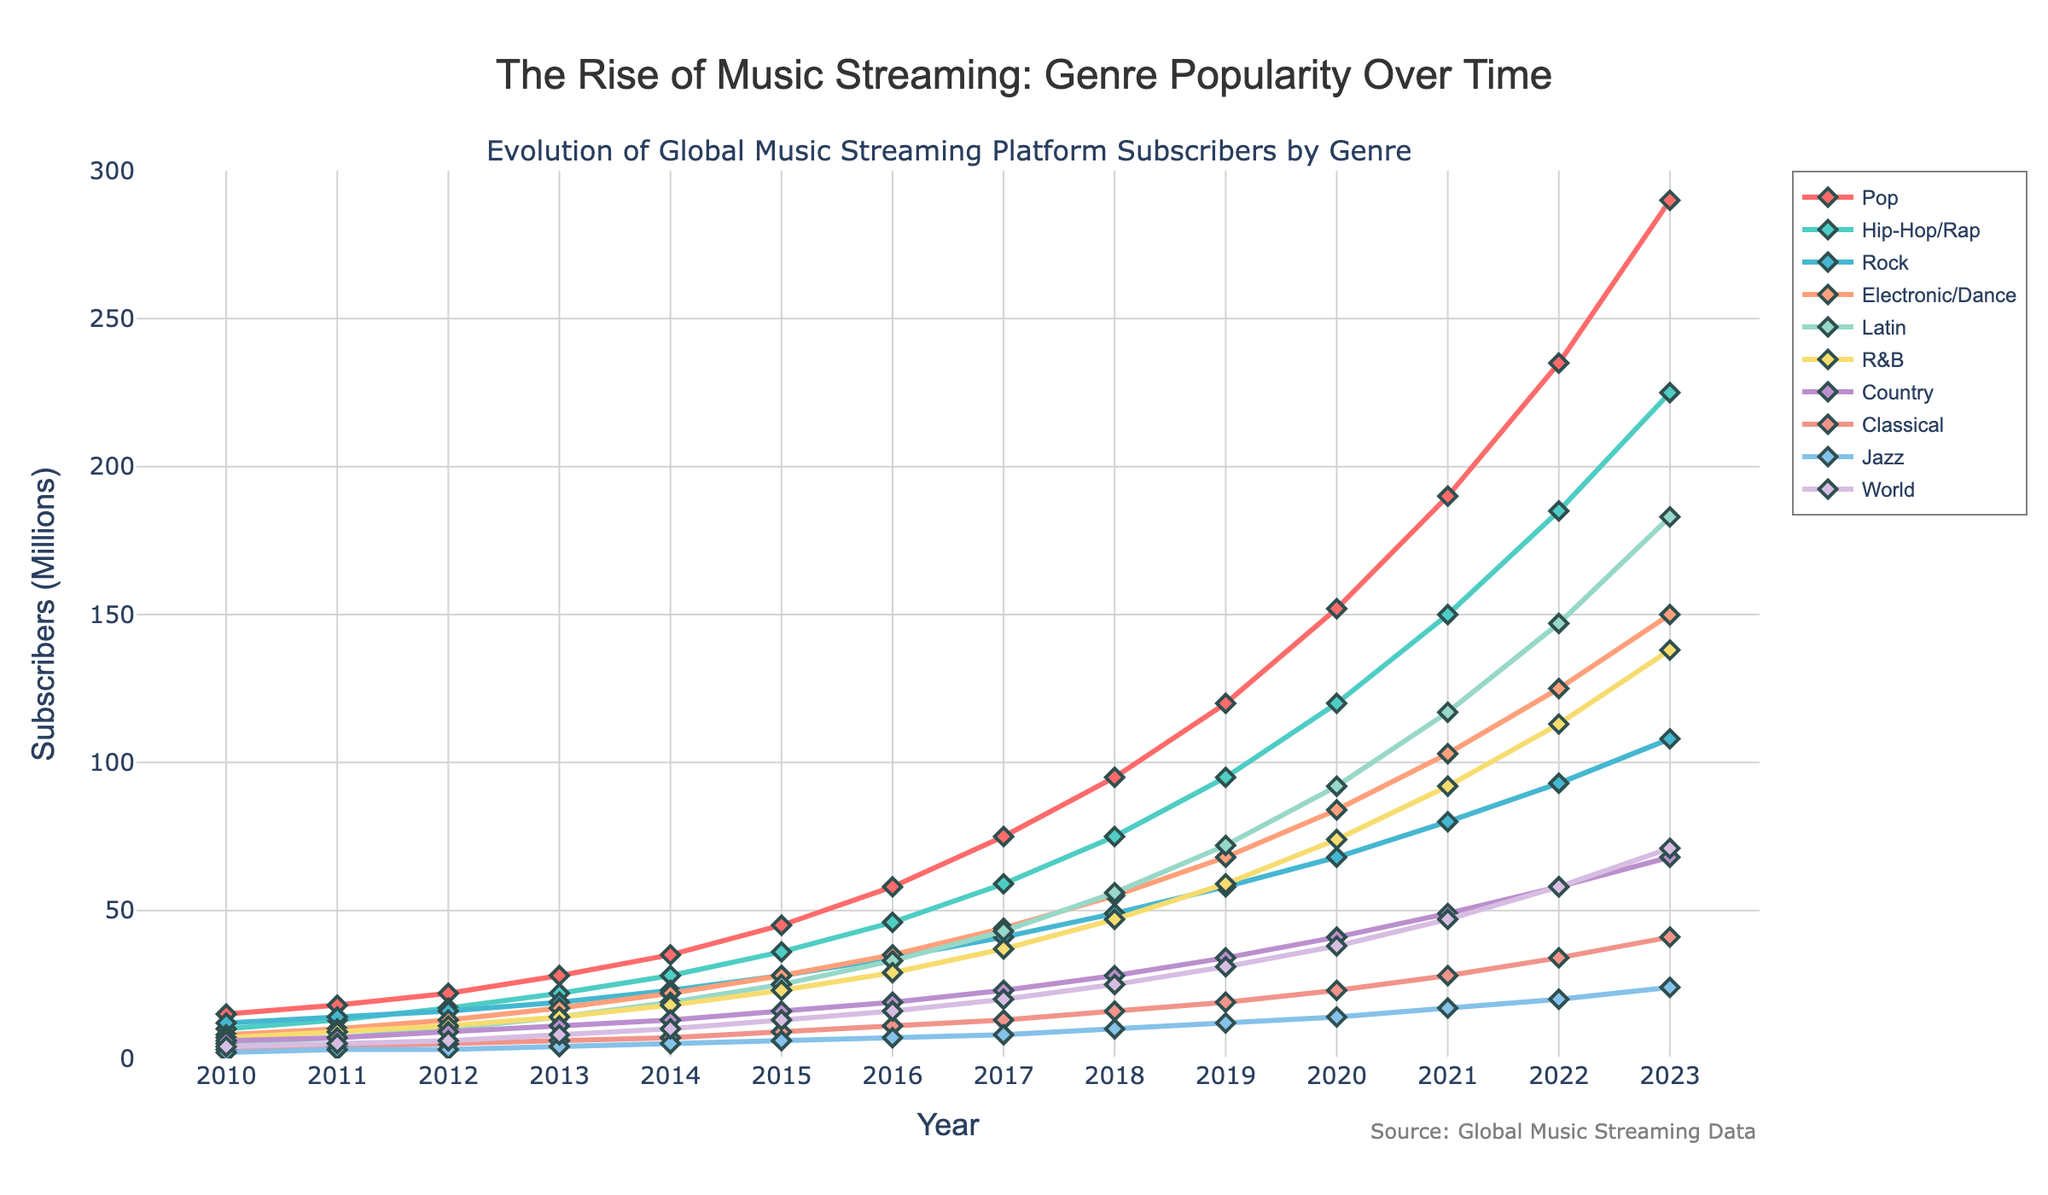Which genre experienced the highest growth in subscribers from 2010 to 2023? By examining the distance between the points for each genre from 2010 to 2023, Pop showed the highest increase, growing from 15M to 290M subscribers.
Answer: Pop How many genres had over 100 million subscribers in 2023? In 2023, the genres exceeding 100M subscribers are Pop (290M), Hip-Hop/Rap (225M), Latin (183M), and Electronic/Dance (150M). There are 4 such genres.
Answer: 4 Which genre saw the least change in subscribers from 2010 to 2023? Calculating the difference for each genre, Jazz grew from 2M to 24M, making it the genre with the smallest increase (22M).
Answer: Jazz What is the total number of subscribers for all genres combined in 2015? Adding the subscribers for each genre in 2015: 45+36+28+28+25+23+16+9+6+13 = 229M total subscribers.
Answer: 229M Which genre had the highest number of subscribers in 2020? The genre with the highest number of subscribers in 2020 is Pop with 152M subscribers.
Answer: Pop Between what two years did the Hip-Hop/Rap genre see the highest increase in subscribers? The highest increase for Hip-Hop/Rap occurred from 2022 to 2023, going from 185M to 225M, a 40M increase.
Answer: 2022 to 2023 Which genres have more than doubled their subscribers from 2015 to 2023? Comparing each genre’s growth: Pop (45 to 290), Hip-Hop/Rap (36 to 225), Rock (28 to 108), Electronic/Dance (28 to 150), Latin (25 to 183), R&B (23 to 138), Country (16 to 68), Classical (9 to 41), Jazz (6 to 24), World (13 to 71). All genres more than doubled.
Answer: All genres How does the growth trend of Classical music compare to that of World music from 2010 to 2023? Classical increased from 3M to 41M, while World grew from 4M to 71M. Both genres grew, but World music grew more rapidly and substantially than Classical music.
Answer: World grew more rapidly What was the average increase in subscribers for Rock from 2010 to 2023 per year? The difference in Rock subscribers from 2010 (12M) to 2023 (108M) is 96M. Dividing by the 13 years: 96M / 13 ≈ 7.38M per year on average.
Answer: 7.38M per year 